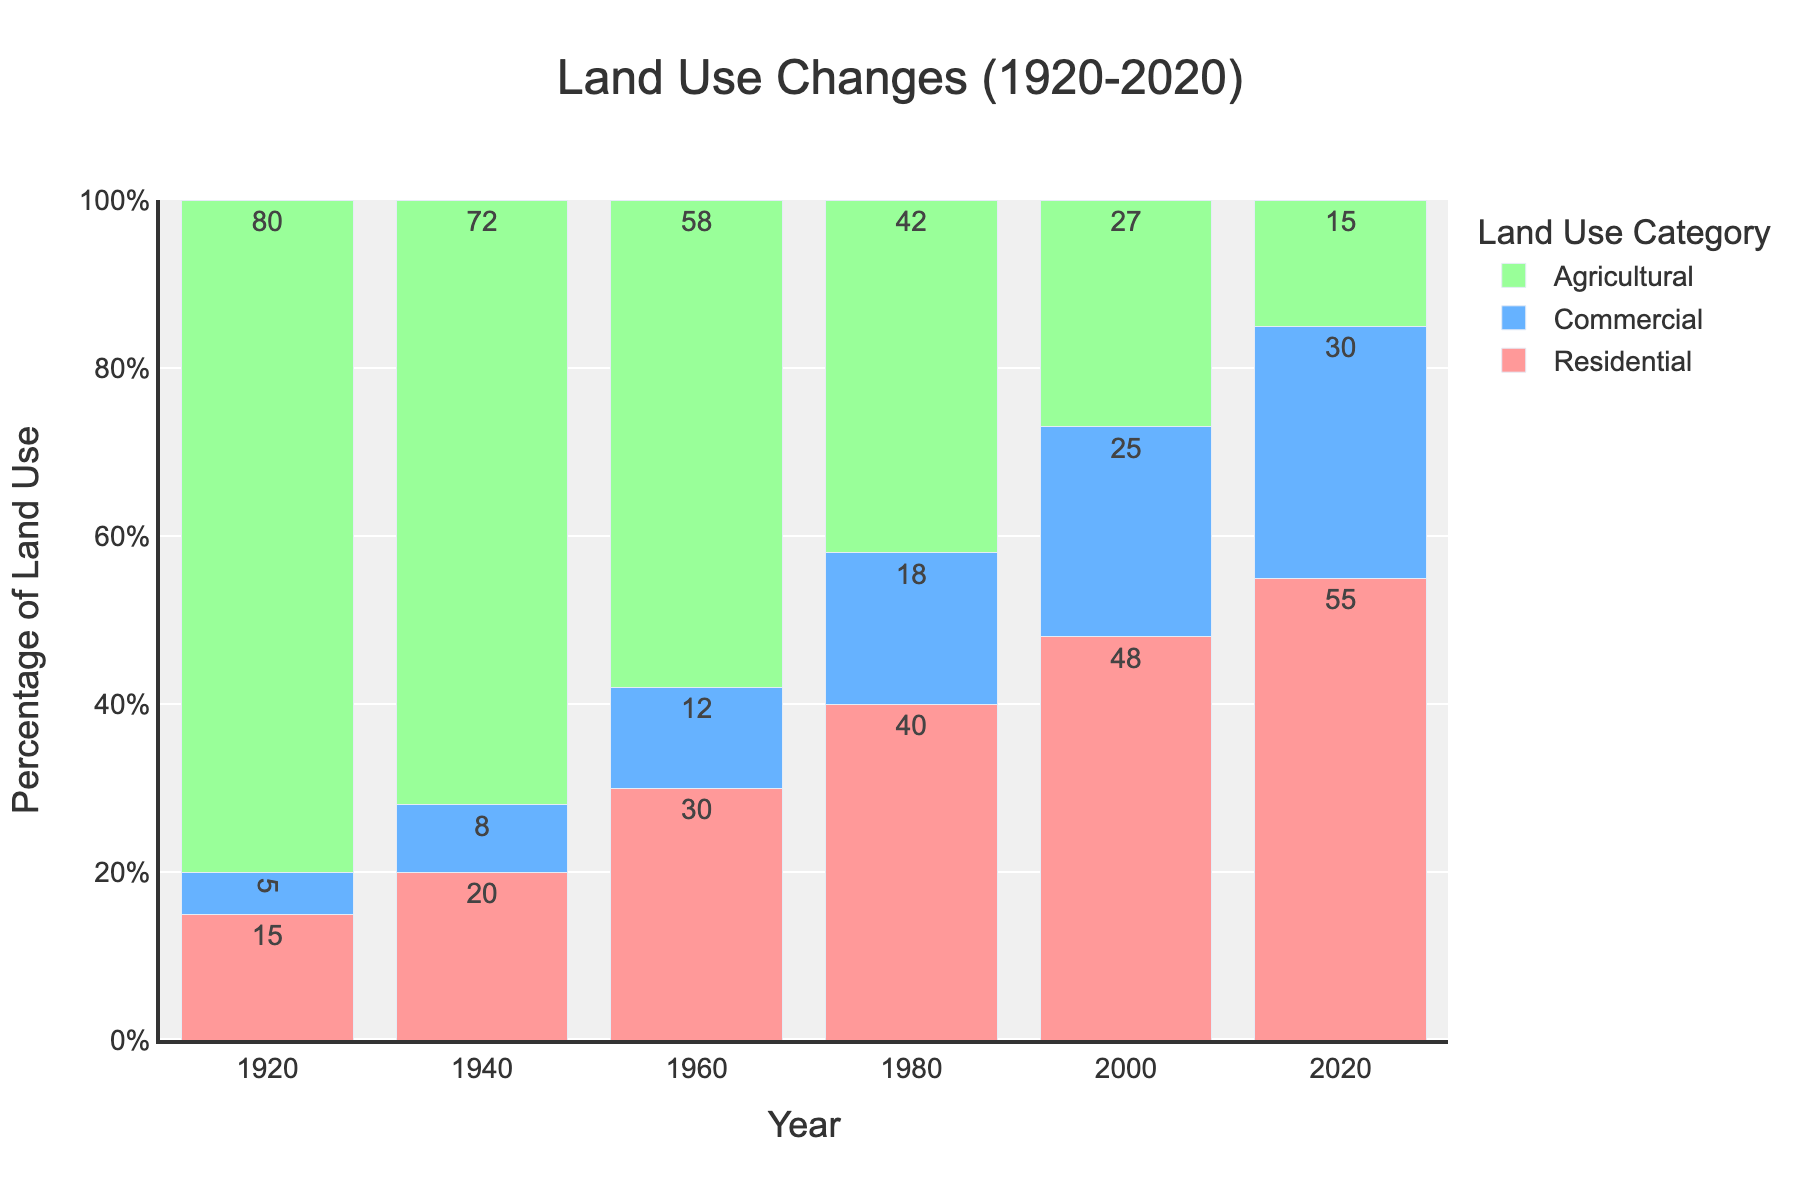what is the percentage increase in residential land use from 1920 to 2020? In 1920, the residential land use was 15%. In 2020, it was 55%. The percentage increase is calculated as (55 - 15) / 15 * 100.
Answer: 266.67% which year had the highest commercial land use? By visually inspecting the heights of the blue bars for commercial land use across the years, we see that the tallest blue bar appears in 2020 with 30%.
Answer: 2020 how did agricultural land use change between 1940 and 1960? In 1940, agricultural land use was 72%. In 1960, it was 58%. The change is calculated as 72 - 58.
Answer: -14% Comparing residential and commercial land use in 2000, what had a higher percentage, and by how much? In 2000, residential land use was 48%, and commercial land use was 25%. The difference is calculated as 48 - 25.
Answer: Residential by 23% what is the total land use percentage in 1980 from all three categories combined? In 1980, residential land use was 40%, commercial was 18%, and agricultural was 42%. The total is calculated as 40 + 18 + 42.
Answer: 100% In which decade did residential land use first exceed 40%? By examining the red bars for residential land use, we notice that in 1980 it reached 40%, and in 2000, it exceeded 40% (48%).
Answer: 2000 how did the residential and commercial land use trends compare from 1920 to 2020? Both residential and commercial land uses showed an increasing trend. Residential started from 15% and went up to 55%, while commercial started from 5% and increased to 30%.
Answer: Both increased which year saw the greatest decrease in agricultural land use from the previous data point? By examining the green bars, the largest drop in agricultural land use occurred between 1960 (58%) and 1980 (42%). The decrease is calculated as 58 - 42.
Answer: 1980 when did agricultural land use fall below 30% for the first time? Examining the green bars, agricultural land use fell below 30% in 2000 when it was 27%.
Answer: 2000 how does the height of the residential bar compare to the commercial bar in 2020? Which one is taller? In 2020, the red bar (residential) is taller than the blue bar (commercial).
Answer: Residential 